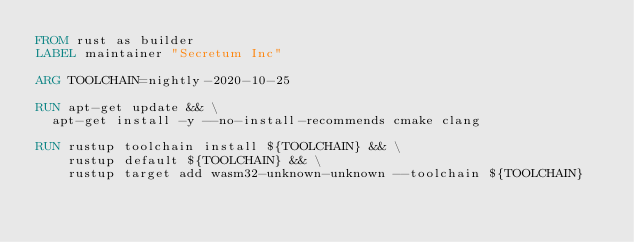<code> <loc_0><loc_0><loc_500><loc_500><_Dockerfile_>FROM rust as builder
LABEL maintainer "Secretum Inc"

ARG TOOLCHAIN=nightly-2020-10-25

RUN apt-get update && \
	apt-get install -y --no-install-recommends cmake clang

RUN rustup toolchain install ${TOOLCHAIN} && \
    rustup default ${TOOLCHAIN} && \
    rustup target add wasm32-unknown-unknown --toolchain ${TOOLCHAIN}
</code> 